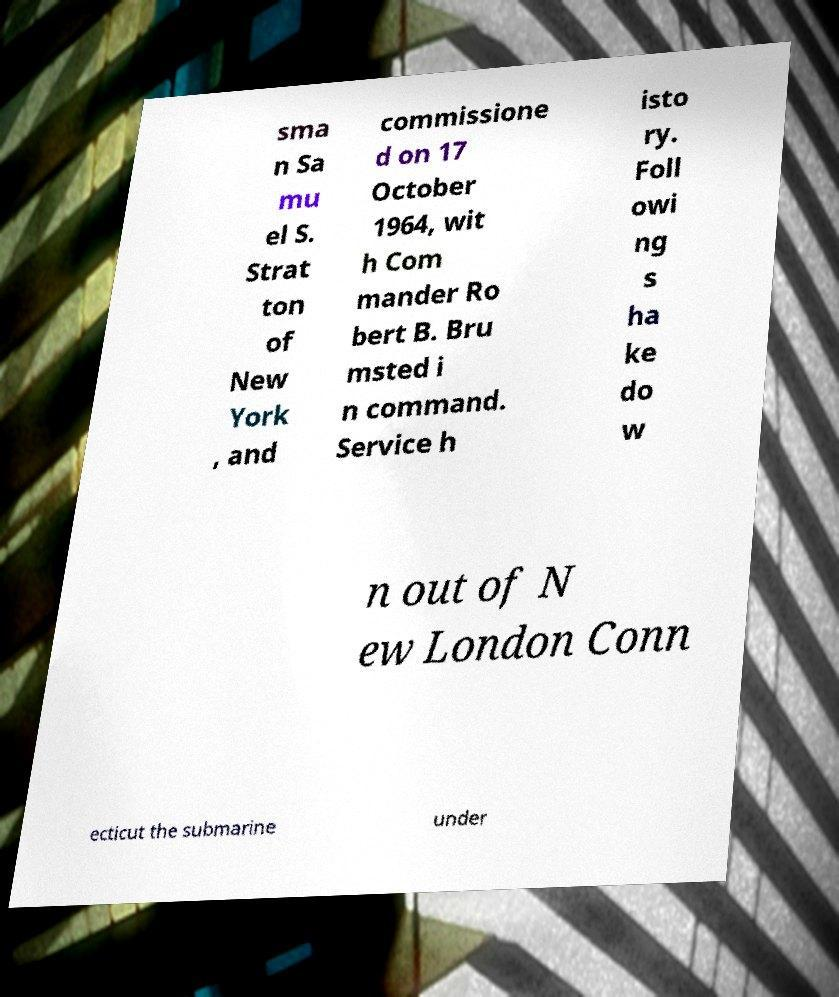What messages or text are displayed in this image? I need them in a readable, typed format. sma n Sa mu el S. Strat ton of New York , and commissione d on 17 October 1964, wit h Com mander Ro bert B. Bru msted i n command. Service h isto ry. Foll owi ng s ha ke do w n out of N ew London Conn ecticut the submarine under 